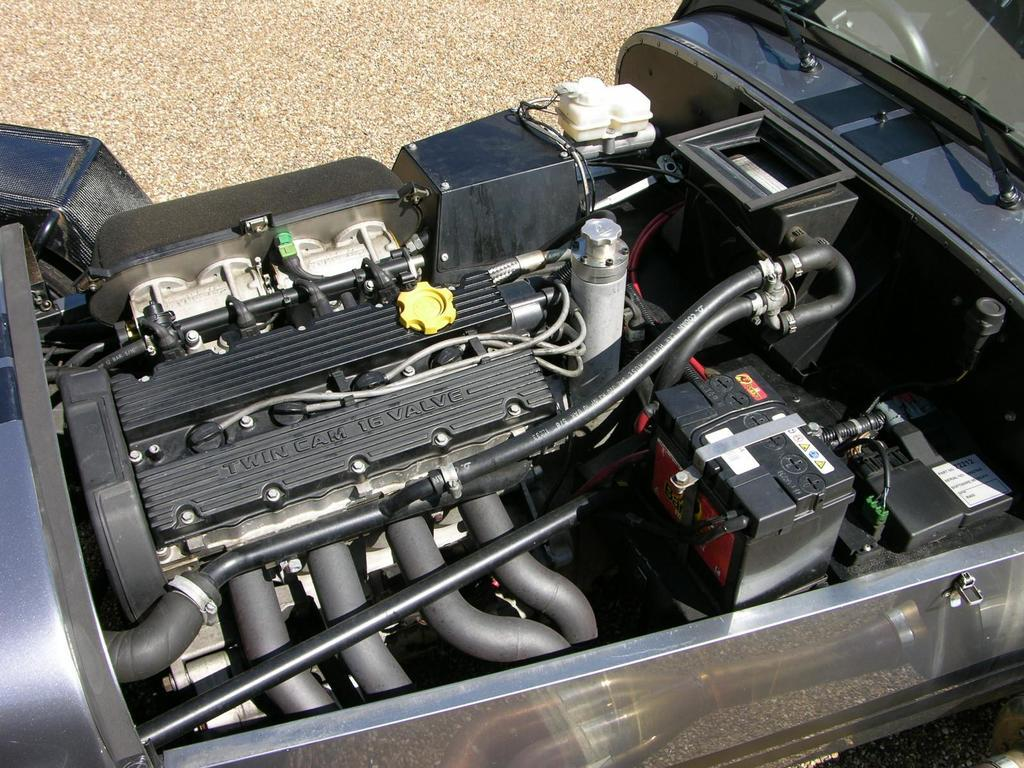What is the main object in the image? There is an engine in the image. What are some of the other objects associated with the engine? There are pipes in the image. Can you describe any other objects present in the image? There are some other objects in the image, but their specific details are not mentioned in the provided facts. How does the engine feel about the distribution of self-hate in the image? There is no mention of self-hate or distribution in the image, so it is not possible to answer this question. 